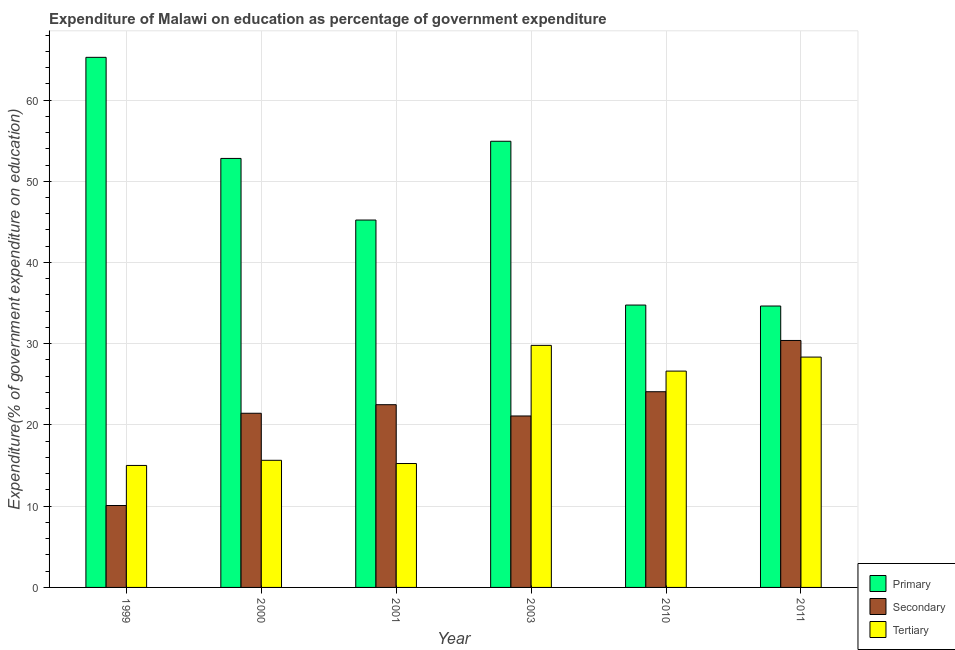How many bars are there on the 4th tick from the left?
Provide a succinct answer. 3. How many bars are there on the 5th tick from the right?
Offer a terse response. 3. What is the label of the 6th group of bars from the left?
Offer a very short reply. 2011. In how many cases, is the number of bars for a given year not equal to the number of legend labels?
Ensure brevity in your answer.  0. What is the expenditure on tertiary education in 2003?
Your answer should be compact. 29.8. Across all years, what is the maximum expenditure on primary education?
Your response must be concise. 65.26. Across all years, what is the minimum expenditure on secondary education?
Make the answer very short. 10.08. What is the total expenditure on secondary education in the graph?
Keep it short and to the point. 129.62. What is the difference between the expenditure on secondary education in 1999 and that in 2003?
Offer a terse response. -11.02. What is the difference between the expenditure on secondary education in 1999 and the expenditure on primary education in 2000?
Offer a terse response. -11.36. What is the average expenditure on primary education per year?
Ensure brevity in your answer.  47.94. In how many years, is the expenditure on primary education greater than 12 %?
Give a very brief answer. 6. What is the ratio of the expenditure on secondary education in 1999 to that in 2010?
Your response must be concise. 0.42. Is the difference between the expenditure on secondary education in 2001 and 2003 greater than the difference between the expenditure on tertiary education in 2001 and 2003?
Offer a terse response. No. What is the difference between the highest and the second highest expenditure on secondary education?
Ensure brevity in your answer.  6.31. What is the difference between the highest and the lowest expenditure on primary education?
Offer a very short reply. 30.61. In how many years, is the expenditure on primary education greater than the average expenditure on primary education taken over all years?
Make the answer very short. 3. Is the sum of the expenditure on primary education in 2000 and 2001 greater than the maximum expenditure on secondary education across all years?
Provide a short and direct response. Yes. What does the 3rd bar from the left in 2010 represents?
Give a very brief answer. Tertiary. What does the 2nd bar from the right in 2003 represents?
Offer a very short reply. Secondary. Is it the case that in every year, the sum of the expenditure on primary education and expenditure on secondary education is greater than the expenditure on tertiary education?
Provide a short and direct response. Yes. How many bars are there?
Give a very brief answer. 18. How many years are there in the graph?
Provide a short and direct response. 6. Are the values on the major ticks of Y-axis written in scientific E-notation?
Your response must be concise. No. Does the graph contain any zero values?
Offer a terse response. No. Where does the legend appear in the graph?
Your answer should be compact. Bottom right. How many legend labels are there?
Your answer should be compact. 3. How are the legend labels stacked?
Your answer should be compact. Vertical. What is the title of the graph?
Provide a succinct answer. Expenditure of Malawi on education as percentage of government expenditure. Does "Coal sources" appear as one of the legend labels in the graph?
Make the answer very short. No. What is the label or title of the Y-axis?
Offer a terse response. Expenditure(% of government expenditure on education). What is the Expenditure(% of government expenditure on education) of Primary in 1999?
Ensure brevity in your answer.  65.26. What is the Expenditure(% of government expenditure on education) of Secondary in 1999?
Your response must be concise. 10.08. What is the Expenditure(% of government expenditure on education) in Tertiary in 1999?
Keep it short and to the point. 15.02. What is the Expenditure(% of government expenditure on education) in Primary in 2000?
Offer a terse response. 52.81. What is the Expenditure(% of government expenditure on education) in Secondary in 2000?
Provide a succinct answer. 21.44. What is the Expenditure(% of government expenditure on education) in Tertiary in 2000?
Your answer should be very brief. 15.65. What is the Expenditure(% of government expenditure on education) of Primary in 2001?
Give a very brief answer. 45.23. What is the Expenditure(% of government expenditure on education) of Secondary in 2001?
Provide a succinct answer. 22.5. What is the Expenditure(% of government expenditure on education) in Tertiary in 2001?
Ensure brevity in your answer.  15.25. What is the Expenditure(% of government expenditure on education) in Primary in 2003?
Your answer should be compact. 54.92. What is the Expenditure(% of government expenditure on education) in Secondary in 2003?
Offer a terse response. 21.11. What is the Expenditure(% of government expenditure on education) of Tertiary in 2003?
Offer a terse response. 29.8. What is the Expenditure(% of government expenditure on education) of Primary in 2010?
Provide a short and direct response. 34.76. What is the Expenditure(% of government expenditure on education) of Secondary in 2010?
Ensure brevity in your answer.  24.09. What is the Expenditure(% of government expenditure on education) of Tertiary in 2010?
Make the answer very short. 26.63. What is the Expenditure(% of government expenditure on education) of Primary in 2011?
Give a very brief answer. 34.64. What is the Expenditure(% of government expenditure on education) of Secondary in 2011?
Offer a terse response. 30.4. What is the Expenditure(% of government expenditure on education) of Tertiary in 2011?
Offer a very short reply. 28.36. Across all years, what is the maximum Expenditure(% of government expenditure on education) of Primary?
Ensure brevity in your answer.  65.26. Across all years, what is the maximum Expenditure(% of government expenditure on education) of Secondary?
Offer a very short reply. 30.4. Across all years, what is the maximum Expenditure(% of government expenditure on education) in Tertiary?
Make the answer very short. 29.8. Across all years, what is the minimum Expenditure(% of government expenditure on education) of Primary?
Provide a short and direct response. 34.64. Across all years, what is the minimum Expenditure(% of government expenditure on education) of Secondary?
Provide a succinct answer. 10.08. Across all years, what is the minimum Expenditure(% of government expenditure on education) in Tertiary?
Ensure brevity in your answer.  15.02. What is the total Expenditure(% of government expenditure on education) of Primary in the graph?
Offer a terse response. 287.62. What is the total Expenditure(% of government expenditure on education) of Secondary in the graph?
Your answer should be very brief. 129.62. What is the total Expenditure(% of government expenditure on education) in Tertiary in the graph?
Your answer should be very brief. 130.7. What is the difference between the Expenditure(% of government expenditure on education) of Primary in 1999 and that in 2000?
Provide a short and direct response. 12.44. What is the difference between the Expenditure(% of government expenditure on education) of Secondary in 1999 and that in 2000?
Provide a succinct answer. -11.36. What is the difference between the Expenditure(% of government expenditure on education) of Tertiary in 1999 and that in 2000?
Make the answer very short. -0.63. What is the difference between the Expenditure(% of government expenditure on education) in Primary in 1999 and that in 2001?
Offer a very short reply. 20.03. What is the difference between the Expenditure(% of government expenditure on education) in Secondary in 1999 and that in 2001?
Offer a terse response. -12.41. What is the difference between the Expenditure(% of government expenditure on education) of Tertiary in 1999 and that in 2001?
Your answer should be compact. -0.24. What is the difference between the Expenditure(% of government expenditure on education) in Primary in 1999 and that in 2003?
Offer a terse response. 10.33. What is the difference between the Expenditure(% of government expenditure on education) in Secondary in 1999 and that in 2003?
Provide a succinct answer. -11.02. What is the difference between the Expenditure(% of government expenditure on education) in Tertiary in 1999 and that in 2003?
Offer a very short reply. -14.78. What is the difference between the Expenditure(% of government expenditure on education) in Primary in 1999 and that in 2010?
Ensure brevity in your answer.  30.5. What is the difference between the Expenditure(% of government expenditure on education) of Secondary in 1999 and that in 2010?
Make the answer very short. -14.01. What is the difference between the Expenditure(% of government expenditure on education) in Tertiary in 1999 and that in 2010?
Offer a very short reply. -11.61. What is the difference between the Expenditure(% of government expenditure on education) of Primary in 1999 and that in 2011?
Offer a very short reply. 30.61. What is the difference between the Expenditure(% of government expenditure on education) of Secondary in 1999 and that in 2011?
Your answer should be very brief. -20.32. What is the difference between the Expenditure(% of government expenditure on education) of Tertiary in 1999 and that in 2011?
Your answer should be very brief. -13.34. What is the difference between the Expenditure(% of government expenditure on education) of Primary in 2000 and that in 2001?
Make the answer very short. 7.59. What is the difference between the Expenditure(% of government expenditure on education) in Secondary in 2000 and that in 2001?
Offer a terse response. -1.05. What is the difference between the Expenditure(% of government expenditure on education) of Tertiary in 2000 and that in 2001?
Ensure brevity in your answer.  0.4. What is the difference between the Expenditure(% of government expenditure on education) in Primary in 2000 and that in 2003?
Provide a succinct answer. -2.11. What is the difference between the Expenditure(% of government expenditure on education) of Secondary in 2000 and that in 2003?
Ensure brevity in your answer.  0.33. What is the difference between the Expenditure(% of government expenditure on education) in Tertiary in 2000 and that in 2003?
Your response must be concise. -14.15. What is the difference between the Expenditure(% of government expenditure on education) of Primary in 2000 and that in 2010?
Your answer should be very brief. 18.05. What is the difference between the Expenditure(% of government expenditure on education) of Secondary in 2000 and that in 2010?
Your response must be concise. -2.65. What is the difference between the Expenditure(% of government expenditure on education) of Tertiary in 2000 and that in 2010?
Give a very brief answer. -10.98. What is the difference between the Expenditure(% of government expenditure on education) in Primary in 2000 and that in 2011?
Provide a succinct answer. 18.17. What is the difference between the Expenditure(% of government expenditure on education) in Secondary in 2000 and that in 2011?
Ensure brevity in your answer.  -8.96. What is the difference between the Expenditure(% of government expenditure on education) of Tertiary in 2000 and that in 2011?
Your answer should be compact. -12.71. What is the difference between the Expenditure(% of government expenditure on education) in Primary in 2001 and that in 2003?
Give a very brief answer. -9.7. What is the difference between the Expenditure(% of government expenditure on education) of Secondary in 2001 and that in 2003?
Your answer should be compact. 1.39. What is the difference between the Expenditure(% of government expenditure on education) of Tertiary in 2001 and that in 2003?
Keep it short and to the point. -14.55. What is the difference between the Expenditure(% of government expenditure on education) in Primary in 2001 and that in 2010?
Give a very brief answer. 10.46. What is the difference between the Expenditure(% of government expenditure on education) of Secondary in 2001 and that in 2010?
Your answer should be compact. -1.59. What is the difference between the Expenditure(% of government expenditure on education) in Tertiary in 2001 and that in 2010?
Keep it short and to the point. -11.38. What is the difference between the Expenditure(% of government expenditure on education) of Primary in 2001 and that in 2011?
Provide a short and direct response. 10.58. What is the difference between the Expenditure(% of government expenditure on education) in Secondary in 2001 and that in 2011?
Make the answer very short. -7.91. What is the difference between the Expenditure(% of government expenditure on education) in Tertiary in 2001 and that in 2011?
Make the answer very short. -13.1. What is the difference between the Expenditure(% of government expenditure on education) of Primary in 2003 and that in 2010?
Keep it short and to the point. 20.16. What is the difference between the Expenditure(% of government expenditure on education) of Secondary in 2003 and that in 2010?
Provide a succinct answer. -2.98. What is the difference between the Expenditure(% of government expenditure on education) of Tertiary in 2003 and that in 2010?
Your answer should be compact. 3.17. What is the difference between the Expenditure(% of government expenditure on education) of Primary in 2003 and that in 2011?
Give a very brief answer. 20.28. What is the difference between the Expenditure(% of government expenditure on education) of Secondary in 2003 and that in 2011?
Give a very brief answer. -9.3. What is the difference between the Expenditure(% of government expenditure on education) in Tertiary in 2003 and that in 2011?
Provide a succinct answer. 1.44. What is the difference between the Expenditure(% of government expenditure on education) in Primary in 2010 and that in 2011?
Give a very brief answer. 0.12. What is the difference between the Expenditure(% of government expenditure on education) in Secondary in 2010 and that in 2011?
Give a very brief answer. -6.31. What is the difference between the Expenditure(% of government expenditure on education) in Tertiary in 2010 and that in 2011?
Offer a terse response. -1.73. What is the difference between the Expenditure(% of government expenditure on education) in Primary in 1999 and the Expenditure(% of government expenditure on education) in Secondary in 2000?
Offer a very short reply. 43.82. What is the difference between the Expenditure(% of government expenditure on education) of Primary in 1999 and the Expenditure(% of government expenditure on education) of Tertiary in 2000?
Your response must be concise. 49.61. What is the difference between the Expenditure(% of government expenditure on education) in Secondary in 1999 and the Expenditure(% of government expenditure on education) in Tertiary in 2000?
Offer a terse response. -5.56. What is the difference between the Expenditure(% of government expenditure on education) of Primary in 1999 and the Expenditure(% of government expenditure on education) of Secondary in 2001?
Your answer should be very brief. 42.76. What is the difference between the Expenditure(% of government expenditure on education) in Primary in 1999 and the Expenditure(% of government expenditure on education) in Tertiary in 2001?
Keep it short and to the point. 50. What is the difference between the Expenditure(% of government expenditure on education) of Secondary in 1999 and the Expenditure(% of government expenditure on education) of Tertiary in 2001?
Ensure brevity in your answer.  -5.17. What is the difference between the Expenditure(% of government expenditure on education) in Primary in 1999 and the Expenditure(% of government expenditure on education) in Secondary in 2003?
Keep it short and to the point. 44.15. What is the difference between the Expenditure(% of government expenditure on education) in Primary in 1999 and the Expenditure(% of government expenditure on education) in Tertiary in 2003?
Offer a terse response. 35.46. What is the difference between the Expenditure(% of government expenditure on education) in Secondary in 1999 and the Expenditure(% of government expenditure on education) in Tertiary in 2003?
Provide a succinct answer. -19.71. What is the difference between the Expenditure(% of government expenditure on education) in Primary in 1999 and the Expenditure(% of government expenditure on education) in Secondary in 2010?
Your answer should be very brief. 41.17. What is the difference between the Expenditure(% of government expenditure on education) of Primary in 1999 and the Expenditure(% of government expenditure on education) of Tertiary in 2010?
Give a very brief answer. 38.63. What is the difference between the Expenditure(% of government expenditure on education) of Secondary in 1999 and the Expenditure(% of government expenditure on education) of Tertiary in 2010?
Your answer should be very brief. -16.55. What is the difference between the Expenditure(% of government expenditure on education) of Primary in 1999 and the Expenditure(% of government expenditure on education) of Secondary in 2011?
Make the answer very short. 34.85. What is the difference between the Expenditure(% of government expenditure on education) in Primary in 1999 and the Expenditure(% of government expenditure on education) in Tertiary in 2011?
Your answer should be very brief. 36.9. What is the difference between the Expenditure(% of government expenditure on education) in Secondary in 1999 and the Expenditure(% of government expenditure on education) in Tertiary in 2011?
Your answer should be compact. -18.27. What is the difference between the Expenditure(% of government expenditure on education) of Primary in 2000 and the Expenditure(% of government expenditure on education) of Secondary in 2001?
Make the answer very short. 30.32. What is the difference between the Expenditure(% of government expenditure on education) of Primary in 2000 and the Expenditure(% of government expenditure on education) of Tertiary in 2001?
Provide a succinct answer. 37.56. What is the difference between the Expenditure(% of government expenditure on education) in Secondary in 2000 and the Expenditure(% of government expenditure on education) in Tertiary in 2001?
Give a very brief answer. 6.19. What is the difference between the Expenditure(% of government expenditure on education) of Primary in 2000 and the Expenditure(% of government expenditure on education) of Secondary in 2003?
Make the answer very short. 31.7. What is the difference between the Expenditure(% of government expenditure on education) of Primary in 2000 and the Expenditure(% of government expenditure on education) of Tertiary in 2003?
Provide a succinct answer. 23.01. What is the difference between the Expenditure(% of government expenditure on education) in Secondary in 2000 and the Expenditure(% of government expenditure on education) in Tertiary in 2003?
Give a very brief answer. -8.36. What is the difference between the Expenditure(% of government expenditure on education) in Primary in 2000 and the Expenditure(% of government expenditure on education) in Secondary in 2010?
Offer a very short reply. 28.72. What is the difference between the Expenditure(% of government expenditure on education) of Primary in 2000 and the Expenditure(% of government expenditure on education) of Tertiary in 2010?
Offer a very short reply. 26.18. What is the difference between the Expenditure(% of government expenditure on education) in Secondary in 2000 and the Expenditure(% of government expenditure on education) in Tertiary in 2010?
Give a very brief answer. -5.19. What is the difference between the Expenditure(% of government expenditure on education) of Primary in 2000 and the Expenditure(% of government expenditure on education) of Secondary in 2011?
Provide a short and direct response. 22.41. What is the difference between the Expenditure(% of government expenditure on education) in Primary in 2000 and the Expenditure(% of government expenditure on education) in Tertiary in 2011?
Provide a succinct answer. 24.46. What is the difference between the Expenditure(% of government expenditure on education) of Secondary in 2000 and the Expenditure(% of government expenditure on education) of Tertiary in 2011?
Your answer should be very brief. -6.92. What is the difference between the Expenditure(% of government expenditure on education) in Primary in 2001 and the Expenditure(% of government expenditure on education) in Secondary in 2003?
Make the answer very short. 24.12. What is the difference between the Expenditure(% of government expenditure on education) in Primary in 2001 and the Expenditure(% of government expenditure on education) in Tertiary in 2003?
Give a very brief answer. 15.43. What is the difference between the Expenditure(% of government expenditure on education) of Secondary in 2001 and the Expenditure(% of government expenditure on education) of Tertiary in 2003?
Give a very brief answer. -7.3. What is the difference between the Expenditure(% of government expenditure on education) of Primary in 2001 and the Expenditure(% of government expenditure on education) of Secondary in 2010?
Provide a succinct answer. 21.14. What is the difference between the Expenditure(% of government expenditure on education) of Primary in 2001 and the Expenditure(% of government expenditure on education) of Tertiary in 2010?
Offer a terse response. 18.6. What is the difference between the Expenditure(% of government expenditure on education) of Secondary in 2001 and the Expenditure(% of government expenditure on education) of Tertiary in 2010?
Give a very brief answer. -4.14. What is the difference between the Expenditure(% of government expenditure on education) in Primary in 2001 and the Expenditure(% of government expenditure on education) in Secondary in 2011?
Provide a short and direct response. 14.82. What is the difference between the Expenditure(% of government expenditure on education) of Primary in 2001 and the Expenditure(% of government expenditure on education) of Tertiary in 2011?
Keep it short and to the point. 16.87. What is the difference between the Expenditure(% of government expenditure on education) in Secondary in 2001 and the Expenditure(% of government expenditure on education) in Tertiary in 2011?
Offer a very short reply. -5.86. What is the difference between the Expenditure(% of government expenditure on education) of Primary in 2003 and the Expenditure(% of government expenditure on education) of Secondary in 2010?
Give a very brief answer. 30.83. What is the difference between the Expenditure(% of government expenditure on education) in Primary in 2003 and the Expenditure(% of government expenditure on education) in Tertiary in 2010?
Your answer should be compact. 28.29. What is the difference between the Expenditure(% of government expenditure on education) of Secondary in 2003 and the Expenditure(% of government expenditure on education) of Tertiary in 2010?
Your response must be concise. -5.52. What is the difference between the Expenditure(% of government expenditure on education) in Primary in 2003 and the Expenditure(% of government expenditure on education) in Secondary in 2011?
Provide a short and direct response. 24.52. What is the difference between the Expenditure(% of government expenditure on education) of Primary in 2003 and the Expenditure(% of government expenditure on education) of Tertiary in 2011?
Provide a succinct answer. 26.57. What is the difference between the Expenditure(% of government expenditure on education) of Secondary in 2003 and the Expenditure(% of government expenditure on education) of Tertiary in 2011?
Offer a terse response. -7.25. What is the difference between the Expenditure(% of government expenditure on education) in Primary in 2010 and the Expenditure(% of government expenditure on education) in Secondary in 2011?
Provide a succinct answer. 4.36. What is the difference between the Expenditure(% of government expenditure on education) of Primary in 2010 and the Expenditure(% of government expenditure on education) of Tertiary in 2011?
Your answer should be compact. 6.4. What is the difference between the Expenditure(% of government expenditure on education) in Secondary in 2010 and the Expenditure(% of government expenditure on education) in Tertiary in 2011?
Your response must be concise. -4.27. What is the average Expenditure(% of government expenditure on education) in Primary per year?
Offer a terse response. 47.94. What is the average Expenditure(% of government expenditure on education) of Secondary per year?
Keep it short and to the point. 21.6. What is the average Expenditure(% of government expenditure on education) of Tertiary per year?
Your response must be concise. 21.78. In the year 1999, what is the difference between the Expenditure(% of government expenditure on education) of Primary and Expenditure(% of government expenditure on education) of Secondary?
Provide a succinct answer. 55.17. In the year 1999, what is the difference between the Expenditure(% of government expenditure on education) of Primary and Expenditure(% of government expenditure on education) of Tertiary?
Your answer should be very brief. 50.24. In the year 1999, what is the difference between the Expenditure(% of government expenditure on education) in Secondary and Expenditure(% of government expenditure on education) in Tertiary?
Ensure brevity in your answer.  -4.93. In the year 2000, what is the difference between the Expenditure(% of government expenditure on education) in Primary and Expenditure(% of government expenditure on education) in Secondary?
Provide a short and direct response. 31.37. In the year 2000, what is the difference between the Expenditure(% of government expenditure on education) in Primary and Expenditure(% of government expenditure on education) in Tertiary?
Offer a very short reply. 37.16. In the year 2000, what is the difference between the Expenditure(% of government expenditure on education) in Secondary and Expenditure(% of government expenditure on education) in Tertiary?
Keep it short and to the point. 5.79. In the year 2001, what is the difference between the Expenditure(% of government expenditure on education) in Primary and Expenditure(% of government expenditure on education) in Secondary?
Provide a succinct answer. 22.73. In the year 2001, what is the difference between the Expenditure(% of government expenditure on education) of Primary and Expenditure(% of government expenditure on education) of Tertiary?
Your answer should be compact. 29.97. In the year 2001, what is the difference between the Expenditure(% of government expenditure on education) of Secondary and Expenditure(% of government expenditure on education) of Tertiary?
Make the answer very short. 7.24. In the year 2003, what is the difference between the Expenditure(% of government expenditure on education) in Primary and Expenditure(% of government expenditure on education) in Secondary?
Offer a very short reply. 33.82. In the year 2003, what is the difference between the Expenditure(% of government expenditure on education) in Primary and Expenditure(% of government expenditure on education) in Tertiary?
Make the answer very short. 25.13. In the year 2003, what is the difference between the Expenditure(% of government expenditure on education) of Secondary and Expenditure(% of government expenditure on education) of Tertiary?
Your answer should be compact. -8.69. In the year 2010, what is the difference between the Expenditure(% of government expenditure on education) in Primary and Expenditure(% of government expenditure on education) in Secondary?
Provide a succinct answer. 10.67. In the year 2010, what is the difference between the Expenditure(% of government expenditure on education) in Primary and Expenditure(% of government expenditure on education) in Tertiary?
Your answer should be very brief. 8.13. In the year 2010, what is the difference between the Expenditure(% of government expenditure on education) of Secondary and Expenditure(% of government expenditure on education) of Tertiary?
Your response must be concise. -2.54. In the year 2011, what is the difference between the Expenditure(% of government expenditure on education) of Primary and Expenditure(% of government expenditure on education) of Secondary?
Your response must be concise. 4.24. In the year 2011, what is the difference between the Expenditure(% of government expenditure on education) of Primary and Expenditure(% of government expenditure on education) of Tertiary?
Provide a succinct answer. 6.29. In the year 2011, what is the difference between the Expenditure(% of government expenditure on education) in Secondary and Expenditure(% of government expenditure on education) in Tertiary?
Give a very brief answer. 2.05. What is the ratio of the Expenditure(% of government expenditure on education) of Primary in 1999 to that in 2000?
Offer a very short reply. 1.24. What is the ratio of the Expenditure(% of government expenditure on education) in Secondary in 1999 to that in 2000?
Ensure brevity in your answer.  0.47. What is the ratio of the Expenditure(% of government expenditure on education) of Tertiary in 1999 to that in 2000?
Your response must be concise. 0.96. What is the ratio of the Expenditure(% of government expenditure on education) of Primary in 1999 to that in 2001?
Provide a short and direct response. 1.44. What is the ratio of the Expenditure(% of government expenditure on education) in Secondary in 1999 to that in 2001?
Keep it short and to the point. 0.45. What is the ratio of the Expenditure(% of government expenditure on education) of Tertiary in 1999 to that in 2001?
Offer a terse response. 0.98. What is the ratio of the Expenditure(% of government expenditure on education) of Primary in 1999 to that in 2003?
Give a very brief answer. 1.19. What is the ratio of the Expenditure(% of government expenditure on education) in Secondary in 1999 to that in 2003?
Provide a short and direct response. 0.48. What is the ratio of the Expenditure(% of government expenditure on education) of Tertiary in 1999 to that in 2003?
Provide a short and direct response. 0.5. What is the ratio of the Expenditure(% of government expenditure on education) in Primary in 1999 to that in 2010?
Offer a very short reply. 1.88. What is the ratio of the Expenditure(% of government expenditure on education) in Secondary in 1999 to that in 2010?
Provide a succinct answer. 0.42. What is the ratio of the Expenditure(% of government expenditure on education) of Tertiary in 1999 to that in 2010?
Your answer should be compact. 0.56. What is the ratio of the Expenditure(% of government expenditure on education) of Primary in 1999 to that in 2011?
Give a very brief answer. 1.88. What is the ratio of the Expenditure(% of government expenditure on education) of Secondary in 1999 to that in 2011?
Give a very brief answer. 0.33. What is the ratio of the Expenditure(% of government expenditure on education) of Tertiary in 1999 to that in 2011?
Provide a succinct answer. 0.53. What is the ratio of the Expenditure(% of government expenditure on education) of Primary in 2000 to that in 2001?
Offer a very short reply. 1.17. What is the ratio of the Expenditure(% of government expenditure on education) in Secondary in 2000 to that in 2001?
Make the answer very short. 0.95. What is the ratio of the Expenditure(% of government expenditure on education) in Tertiary in 2000 to that in 2001?
Your answer should be compact. 1.03. What is the ratio of the Expenditure(% of government expenditure on education) in Primary in 2000 to that in 2003?
Give a very brief answer. 0.96. What is the ratio of the Expenditure(% of government expenditure on education) of Secondary in 2000 to that in 2003?
Make the answer very short. 1.02. What is the ratio of the Expenditure(% of government expenditure on education) of Tertiary in 2000 to that in 2003?
Your answer should be compact. 0.53. What is the ratio of the Expenditure(% of government expenditure on education) in Primary in 2000 to that in 2010?
Provide a succinct answer. 1.52. What is the ratio of the Expenditure(% of government expenditure on education) in Secondary in 2000 to that in 2010?
Your response must be concise. 0.89. What is the ratio of the Expenditure(% of government expenditure on education) in Tertiary in 2000 to that in 2010?
Provide a short and direct response. 0.59. What is the ratio of the Expenditure(% of government expenditure on education) of Primary in 2000 to that in 2011?
Ensure brevity in your answer.  1.52. What is the ratio of the Expenditure(% of government expenditure on education) of Secondary in 2000 to that in 2011?
Your response must be concise. 0.71. What is the ratio of the Expenditure(% of government expenditure on education) in Tertiary in 2000 to that in 2011?
Offer a very short reply. 0.55. What is the ratio of the Expenditure(% of government expenditure on education) of Primary in 2001 to that in 2003?
Provide a succinct answer. 0.82. What is the ratio of the Expenditure(% of government expenditure on education) in Secondary in 2001 to that in 2003?
Ensure brevity in your answer.  1.07. What is the ratio of the Expenditure(% of government expenditure on education) of Tertiary in 2001 to that in 2003?
Your answer should be compact. 0.51. What is the ratio of the Expenditure(% of government expenditure on education) in Primary in 2001 to that in 2010?
Your answer should be very brief. 1.3. What is the ratio of the Expenditure(% of government expenditure on education) of Secondary in 2001 to that in 2010?
Offer a very short reply. 0.93. What is the ratio of the Expenditure(% of government expenditure on education) of Tertiary in 2001 to that in 2010?
Provide a short and direct response. 0.57. What is the ratio of the Expenditure(% of government expenditure on education) in Primary in 2001 to that in 2011?
Make the answer very short. 1.31. What is the ratio of the Expenditure(% of government expenditure on education) in Secondary in 2001 to that in 2011?
Your answer should be very brief. 0.74. What is the ratio of the Expenditure(% of government expenditure on education) of Tertiary in 2001 to that in 2011?
Your answer should be compact. 0.54. What is the ratio of the Expenditure(% of government expenditure on education) of Primary in 2003 to that in 2010?
Your response must be concise. 1.58. What is the ratio of the Expenditure(% of government expenditure on education) of Secondary in 2003 to that in 2010?
Your answer should be compact. 0.88. What is the ratio of the Expenditure(% of government expenditure on education) in Tertiary in 2003 to that in 2010?
Give a very brief answer. 1.12. What is the ratio of the Expenditure(% of government expenditure on education) of Primary in 2003 to that in 2011?
Give a very brief answer. 1.59. What is the ratio of the Expenditure(% of government expenditure on education) of Secondary in 2003 to that in 2011?
Offer a very short reply. 0.69. What is the ratio of the Expenditure(% of government expenditure on education) in Tertiary in 2003 to that in 2011?
Ensure brevity in your answer.  1.05. What is the ratio of the Expenditure(% of government expenditure on education) of Primary in 2010 to that in 2011?
Your answer should be compact. 1. What is the ratio of the Expenditure(% of government expenditure on education) of Secondary in 2010 to that in 2011?
Your answer should be compact. 0.79. What is the ratio of the Expenditure(% of government expenditure on education) of Tertiary in 2010 to that in 2011?
Your response must be concise. 0.94. What is the difference between the highest and the second highest Expenditure(% of government expenditure on education) of Primary?
Offer a terse response. 10.33. What is the difference between the highest and the second highest Expenditure(% of government expenditure on education) in Secondary?
Give a very brief answer. 6.31. What is the difference between the highest and the second highest Expenditure(% of government expenditure on education) of Tertiary?
Offer a terse response. 1.44. What is the difference between the highest and the lowest Expenditure(% of government expenditure on education) of Primary?
Your answer should be compact. 30.61. What is the difference between the highest and the lowest Expenditure(% of government expenditure on education) in Secondary?
Keep it short and to the point. 20.32. What is the difference between the highest and the lowest Expenditure(% of government expenditure on education) of Tertiary?
Ensure brevity in your answer.  14.78. 